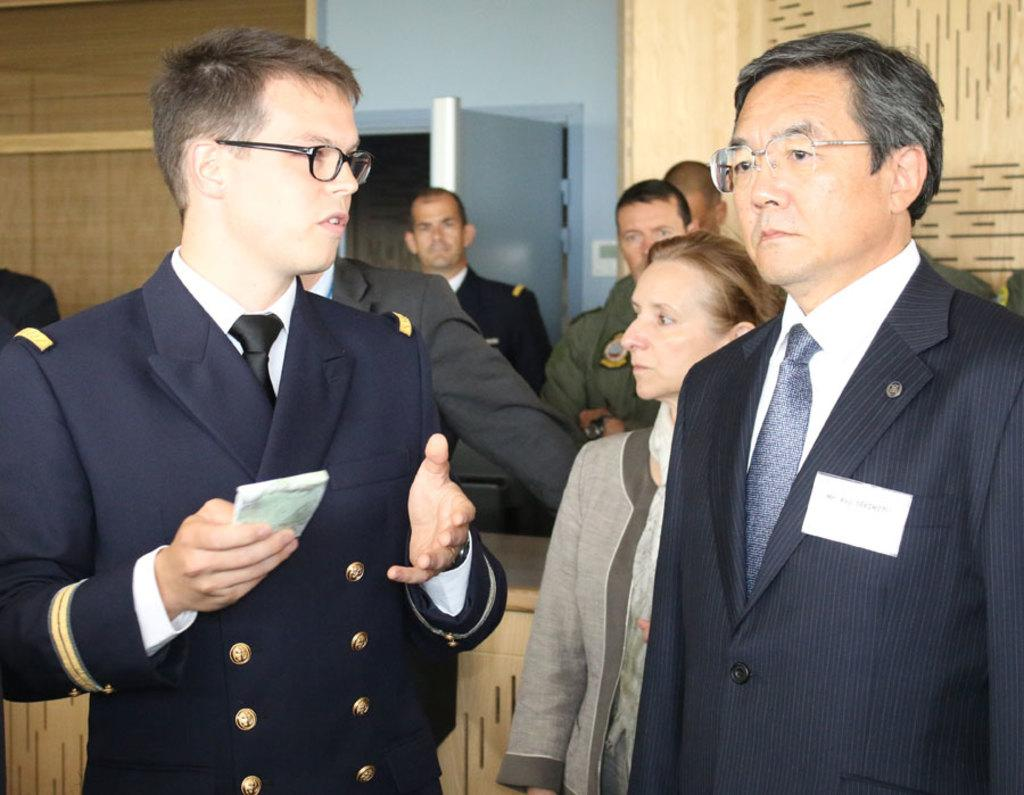How many people are in the image? There is a group of persons in the image. What are the persons wearing? The persons are wearing suits. What are the persons doing in the image? The persons are standing. What can be seen in the background of the image? There is a wall and a door in the background of the image. Can you tell me how many yaks are visible in the image? There are no yaks present in the image. What type of fruit is being held by the persons in the image? The persons are not holding any fruit in the image. 